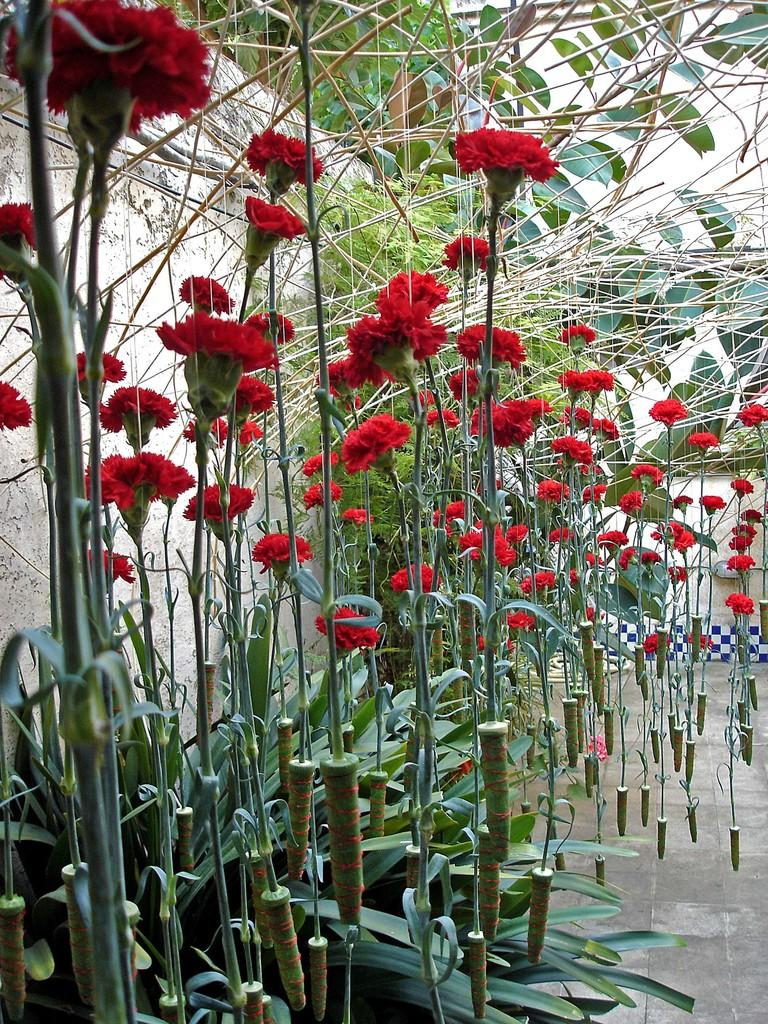What type of plants are present in the image? There are plants with red flowers in the image. What is the background of the image? There is a wall in the image. What is the surface on which the plants are placed? There is a floor in the image. What type of bridge can be seen connecting the plants in the image? There is no bridge present in the image; it only features plants with red flowers, a wall, and a floor. 